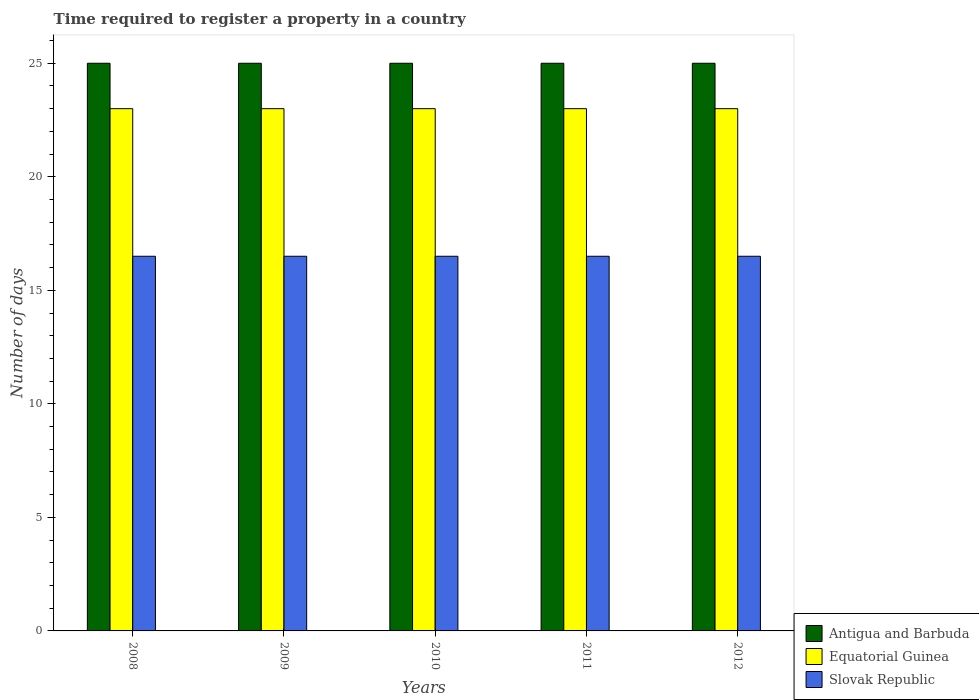Are the number of bars per tick equal to the number of legend labels?
Make the answer very short. Yes. Are the number of bars on each tick of the X-axis equal?
Give a very brief answer. Yes. How many bars are there on the 3rd tick from the left?
Keep it short and to the point. 3. How many bars are there on the 2nd tick from the right?
Provide a succinct answer. 3. What is the label of the 4th group of bars from the left?
Provide a succinct answer. 2011. What is the number of days required to register a property in Slovak Republic in 2012?
Make the answer very short. 16.5. Across all years, what is the maximum number of days required to register a property in Slovak Republic?
Offer a terse response. 16.5. Across all years, what is the minimum number of days required to register a property in Antigua and Barbuda?
Your response must be concise. 25. In which year was the number of days required to register a property in Slovak Republic minimum?
Make the answer very short. 2008. What is the total number of days required to register a property in Equatorial Guinea in the graph?
Give a very brief answer. 115. What is the difference between the number of days required to register a property in Slovak Republic in 2008 and the number of days required to register a property in Equatorial Guinea in 2012?
Ensure brevity in your answer.  -6.5. What is the average number of days required to register a property in Equatorial Guinea per year?
Your answer should be very brief. 23. In the year 2010, what is the difference between the number of days required to register a property in Equatorial Guinea and number of days required to register a property in Antigua and Barbuda?
Offer a very short reply. -2. Is the difference between the number of days required to register a property in Equatorial Guinea in 2010 and 2011 greater than the difference between the number of days required to register a property in Antigua and Barbuda in 2010 and 2011?
Give a very brief answer. No. What does the 1st bar from the left in 2011 represents?
Offer a very short reply. Antigua and Barbuda. What does the 1st bar from the right in 2011 represents?
Give a very brief answer. Slovak Republic. Is it the case that in every year, the sum of the number of days required to register a property in Antigua and Barbuda and number of days required to register a property in Equatorial Guinea is greater than the number of days required to register a property in Slovak Republic?
Give a very brief answer. Yes. How many bars are there?
Make the answer very short. 15. How many years are there in the graph?
Ensure brevity in your answer.  5. Are the values on the major ticks of Y-axis written in scientific E-notation?
Your response must be concise. No. Does the graph contain any zero values?
Offer a very short reply. No. Where does the legend appear in the graph?
Offer a terse response. Bottom right. What is the title of the graph?
Make the answer very short. Time required to register a property in a country. What is the label or title of the Y-axis?
Offer a very short reply. Number of days. What is the Number of days of Antigua and Barbuda in 2008?
Keep it short and to the point. 25. What is the Number of days of Equatorial Guinea in 2008?
Provide a short and direct response. 23. What is the Number of days of Slovak Republic in 2008?
Your answer should be compact. 16.5. What is the Number of days of Slovak Republic in 2009?
Ensure brevity in your answer.  16.5. What is the Number of days of Equatorial Guinea in 2010?
Your answer should be compact. 23. What is the Number of days of Antigua and Barbuda in 2011?
Offer a very short reply. 25. What is the Number of days of Slovak Republic in 2011?
Keep it short and to the point. 16.5. What is the Number of days in Slovak Republic in 2012?
Make the answer very short. 16.5. Across all years, what is the minimum Number of days in Equatorial Guinea?
Provide a succinct answer. 23. What is the total Number of days of Antigua and Barbuda in the graph?
Ensure brevity in your answer.  125. What is the total Number of days in Equatorial Guinea in the graph?
Your answer should be very brief. 115. What is the total Number of days in Slovak Republic in the graph?
Your answer should be compact. 82.5. What is the difference between the Number of days of Equatorial Guinea in 2008 and that in 2009?
Your response must be concise. 0. What is the difference between the Number of days in Antigua and Barbuda in 2008 and that in 2010?
Ensure brevity in your answer.  0. What is the difference between the Number of days of Equatorial Guinea in 2008 and that in 2010?
Your answer should be very brief. 0. What is the difference between the Number of days in Slovak Republic in 2008 and that in 2010?
Your answer should be very brief. 0. What is the difference between the Number of days of Equatorial Guinea in 2008 and that in 2011?
Keep it short and to the point. 0. What is the difference between the Number of days in Slovak Republic in 2008 and that in 2011?
Your response must be concise. 0. What is the difference between the Number of days of Antigua and Barbuda in 2008 and that in 2012?
Offer a very short reply. 0. What is the difference between the Number of days in Antigua and Barbuda in 2009 and that in 2011?
Offer a very short reply. 0. What is the difference between the Number of days of Slovak Republic in 2009 and that in 2011?
Provide a succinct answer. 0. What is the difference between the Number of days in Equatorial Guinea in 2009 and that in 2012?
Make the answer very short. 0. What is the difference between the Number of days of Slovak Republic in 2010 and that in 2011?
Provide a succinct answer. 0. What is the difference between the Number of days of Antigua and Barbuda in 2010 and that in 2012?
Your response must be concise. 0. What is the difference between the Number of days of Equatorial Guinea in 2010 and that in 2012?
Make the answer very short. 0. What is the difference between the Number of days in Slovak Republic in 2011 and that in 2012?
Give a very brief answer. 0. What is the difference between the Number of days in Antigua and Barbuda in 2008 and the Number of days in Slovak Republic in 2009?
Provide a succinct answer. 8.5. What is the difference between the Number of days in Equatorial Guinea in 2008 and the Number of days in Slovak Republic in 2009?
Make the answer very short. 6.5. What is the difference between the Number of days in Equatorial Guinea in 2008 and the Number of days in Slovak Republic in 2010?
Give a very brief answer. 6.5. What is the difference between the Number of days in Antigua and Barbuda in 2008 and the Number of days in Equatorial Guinea in 2011?
Your answer should be very brief. 2. What is the difference between the Number of days of Antigua and Barbuda in 2008 and the Number of days of Slovak Republic in 2011?
Provide a short and direct response. 8.5. What is the difference between the Number of days in Antigua and Barbuda in 2008 and the Number of days in Equatorial Guinea in 2012?
Make the answer very short. 2. What is the difference between the Number of days of Antigua and Barbuda in 2008 and the Number of days of Slovak Republic in 2012?
Provide a succinct answer. 8.5. What is the difference between the Number of days of Antigua and Barbuda in 2009 and the Number of days of Slovak Republic in 2011?
Keep it short and to the point. 8.5. What is the difference between the Number of days of Antigua and Barbuda in 2009 and the Number of days of Equatorial Guinea in 2012?
Your answer should be very brief. 2. What is the difference between the Number of days of Equatorial Guinea in 2009 and the Number of days of Slovak Republic in 2012?
Provide a succinct answer. 6.5. What is the difference between the Number of days of Antigua and Barbuda in 2010 and the Number of days of Equatorial Guinea in 2011?
Offer a terse response. 2. What is the difference between the Number of days of Antigua and Barbuda in 2010 and the Number of days of Slovak Republic in 2011?
Ensure brevity in your answer.  8.5. What is the difference between the Number of days of Equatorial Guinea in 2010 and the Number of days of Slovak Republic in 2011?
Your response must be concise. 6.5. What is the difference between the Number of days of Equatorial Guinea in 2010 and the Number of days of Slovak Republic in 2012?
Make the answer very short. 6.5. What is the difference between the Number of days of Antigua and Barbuda in 2011 and the Number of days of Slovak Republic in 2012?
Keep it short and to the point. 8.5. What is the difference between the Number of days in Equatorial Guinea in 2011 and the Number of days in Slovak Republic in 2012?
Give a very brief answer. 6.5. What is the average Number of days of Antigua and Barbuda per year?
Your answer should be very brief. 25. What is the average Number of days of Equatorial Guinea per year?
Ensure brevity in your answer.  23. In the year 2008, what is the difference between the Number of days in Antigua and Barbuda and Number of days in Slovak Republic?
Your answer should be compact. 8.5. In the year 2010, what is the difference between the Number of days in Antigua and Barbuda and Number of days in Slovak Republic?
Offer a terse response. 8.5. In the year 2010, what is the difference between the Number of days in Equatorial Guinea and Number of days in Slovak Republic?
Your answer should be compact. 6.5. In the year 2011, what is the difference between the Number of days in Antigua and Barbuda and Number of days in Equatorial Guinea?
Provide a succinct answer. 2. In the year 2011, what is the difference between the Number of days in Antigua and Barbuda and Number of days in Slovak Republic?
Keep it short and to the point. 8.5. In the year 2011, what is the difference between the Number of days of Equatorial Guinea and Number of days of Slovak Republic?
Provide a short and direct response. 6.5. In the year 2012, what is the difference between the Number of days in Equatorial Guinea and Number of days in Slovak Republic?
Provide a succinct answer. 6.5. What is the ratio of the Number of days in Antigua and Barbuda in 2008 to that in 2009?
Your response must be concise. 1. What is the ratio of the Number of days in Equatorial Guinea in 2008 to that in 2009?
Your response must be concise. 1. What is the ratio of the Number of days of Equatorial Guinea in 2008 to that in 2010?
Provide a succinct answer. 1. What is the ratio of the Number of days in Antigua and Barbuda in 2008 to that in 2011?
Provide a short and direct response. 1. What is the ratio of the Number of days in Equatorial Guinea in 2008 to that in 2011?
Your answer should be compact. 1. What is the ratio of the Number of days of Slovak Republic in 2008 to that in 2011?
Offer a terse response. 1. What is the ratio of the Number of days in Antigua and Barbuda in 2008 to that in 2012?
Your response must be concise. 1. What is the ratio of the Number of days in Equatorial Guinea in 2008 to that in 2012?
Give a very brief answer. 1. What is the ratio of the Number of days in Slovak Republic in 2008 to that in 2012?
Your answer should be compact. 1. What is the ratio of the Number of days of Antigua and Barbuda in 2009 to that in 2010?
Offer a very short reply. 1. What is the ratio of the Number of days of Antigua and Barbuda in 2009 to that in 2011?
Ensure brevity in your answer.  1. What is the ratio of the Number of days of Equatorial Guinea in 2009 to that in 2011?
Your answer should be compact. 1. What is the ratio of the Number of days of Slovak Republic in 2009 to that in 2011?
Your answer should be very brief. 1. What is the ratio of the Number of days in Equatorial Guinea in 2009 to that in 2012?
Offer a very short reply. 1. What is the ratio of the Number of days of Slovak Republic in 2009 to that in 2012?
Provide a succinct answer. 1. What is the ratio of the Number of days in Antigua and Barbuda in 2010 to that in 2011?
Make the answer very short. 1. What is the ratio of the Number of days in Equatorial Guinea in 2010 to that in 2011?
Your response must be concise. 1. What is the ratio of the Number of days of Equatorial Guinea in 2010 to that in 2012?
Offer a terse response. 1. What is the ratio of the Number of days of Slovak Republic in 2010 to that in 2012?
Provide a short and direct response. 1. What is the ratio of the Number of days of Slovak Republic in 2011 to that in 2012?
Provide a succinct answer. 1. What is the difference between the highest and the lowest Number of days in Antigua and Barbuda?
Ensure brevity in your answer.  0. 